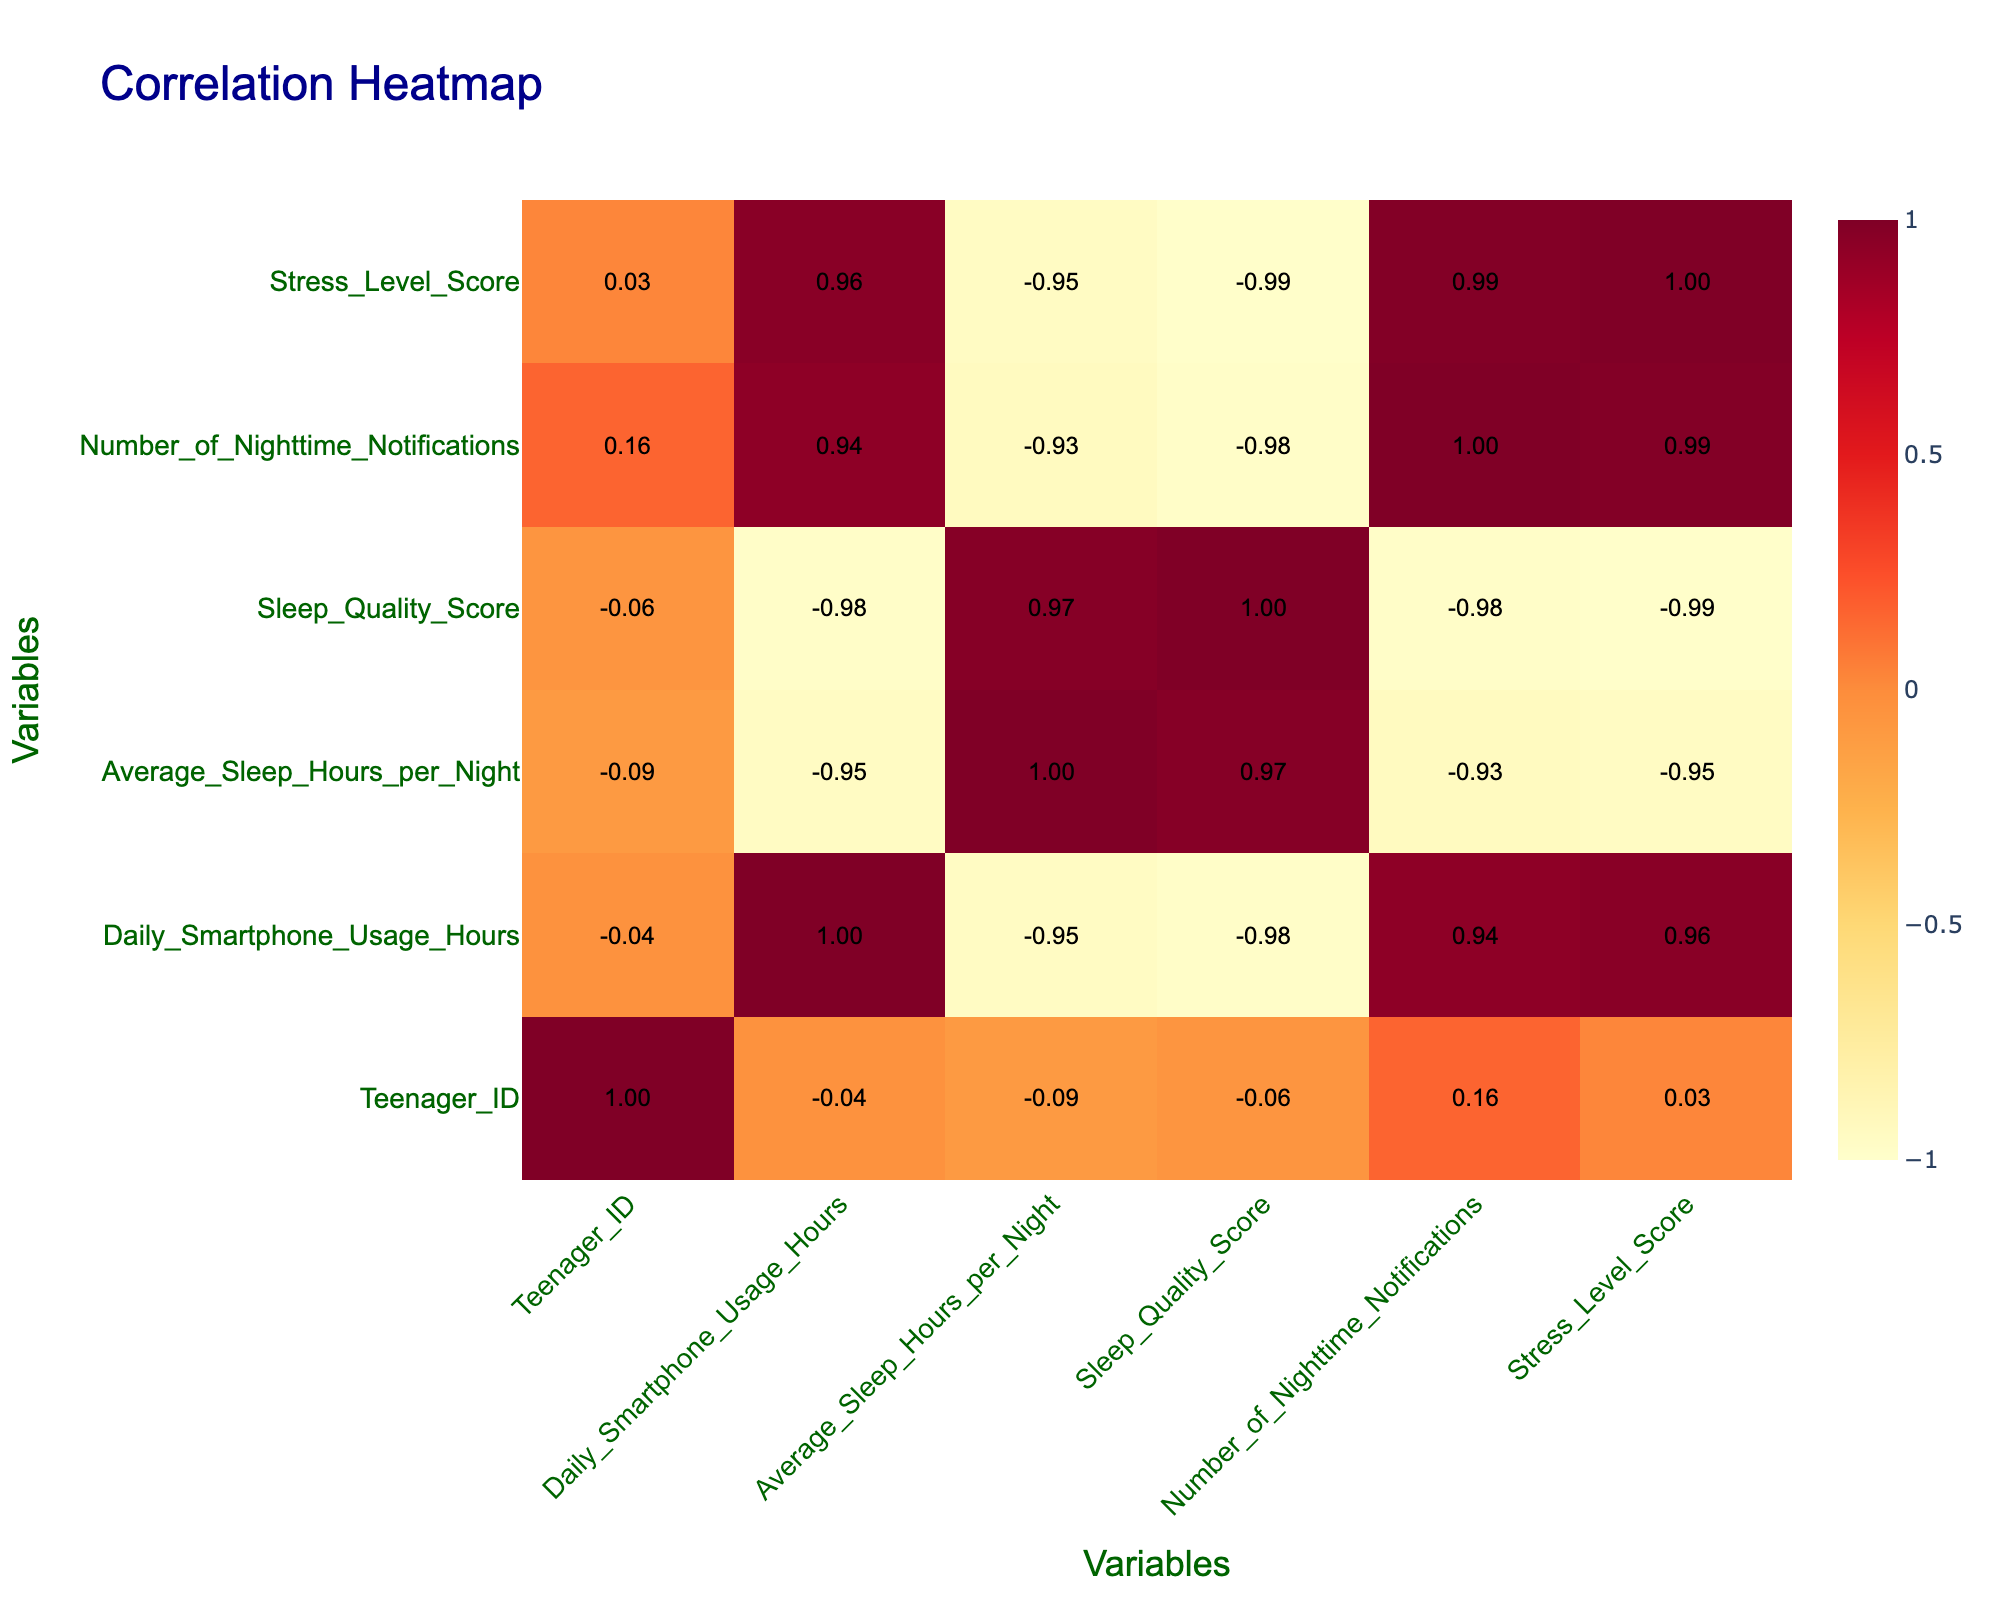What is the correlation between daily smartphone usage hours and average sleep hours per night? According to the correlation table, the correlation value between daily smartphone usage hours and average sleep hours per night is -0.87, indicating a strong negative correlation. This suggests that, generally, as smartphone usage increases, average sleep hours decrease.
Answer: -0.87 Is it true that there is a positive correlation between sleep quality score and average sleep hours per night? The correlation value between sleep quality score and average sleep hours per night is 0.82, which is a strong positive correlation. This suggests that higher sleep quality is associated with more hours of sleep.
Answer: Yes How many teenagers have a sleep quality score of less than 5? From the data, the teenagers with IDs 1, 3, and 5 have sleep quality scores of 5, 4, and 3 respectively. Therefore, there are 3 teenagers with a sleep quality score of less than 5.
Answer: 3 What is the average sleep quality score of teenagers who use their smartphones for more than 6 hours daily? Analyzing the data, teenagers with daily smartphone usage of more than 6 hours are those with IDs 1, 3, 5, and 8, whose sleep quality scores are 5, 4, 3, and 2 respectively. The average is calculated as (5 + 4 + 3 + 2) / 4 = 3.5.
Answer: 3.5 Is there a correlation between the number of nighttime notifications and stress level score? The correlation value between the number of nighttime notifications and the stress level score is 0.87, indicating a strong positive correlation. This suggests that as the number of nighttime notifications increases, so does the stress level.
Answer: Yes What is the difference in stress level scores between teenagers who receive fewer than 5 nighttime notifications and those who receive more than 20? Analyzing the data, teenagers with fewer than 5 nighttime notifications (IDs 2, 4, 6, and 7) have stress level scores of 4, 3, 5, and 4, respectively. Their average score is (4 + 3 + 5 + 4) / 4 = 4. For those receiving more than 20 notifications (IDs 5 and 8), the scores are 9 and 10, averaging (9 + 10) / 2 = 9.5. The difference is 9.5 - 4 = 5.5.
Answer: 5.5 What is the sleep quality score of the teenager who sleeps the least? The teenager with the least average sleep hours per night is teenager ID 5 who sleeps for 4 hours and has a sleep quality score of 3.
Answer: 3 How many teenagers have a sleep quality score of 9 or higher? Checking the data, only teenagers with IDs 2 and 4 have sleep quality scores of 8 and 9, respectively. Thus, there are 2 teenagers with scores of 9 or higher.
Answer: 2 